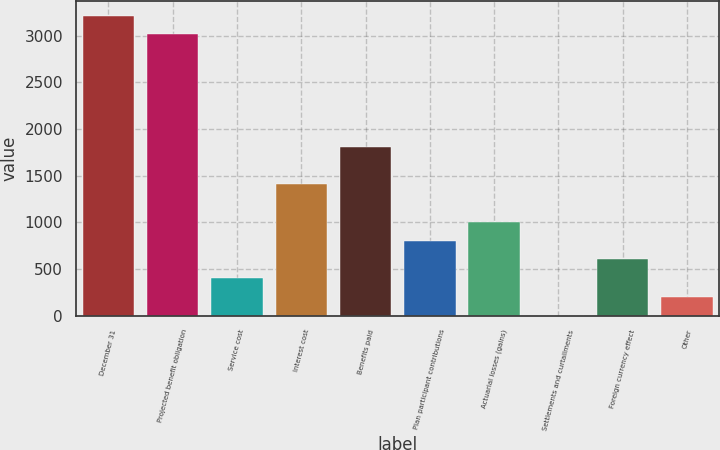Convert chart to OTSL. <chart><loc_0><loc_0><loc_500><loc_500><bar_chart><fcel>December 31<fcel>Projected benefit obligation<fcel>Service cost<fcel>Interest cost<fcel>Benefits paid<fcel>Plan participant contributions<fcel>Actuarial losses (gains)<fcel>Settlements and curtailments<fcel>Foreign currency effect<fcel>Other<nl><fcel>3217.28<fcel>3016.23<fcel>402.58<fcel>1407.83<fcel>1809.93<fcel>804.68<fcel>1005.73<fcel>0.48<fcel>603.63<fcel>201.53<nl></chart> 